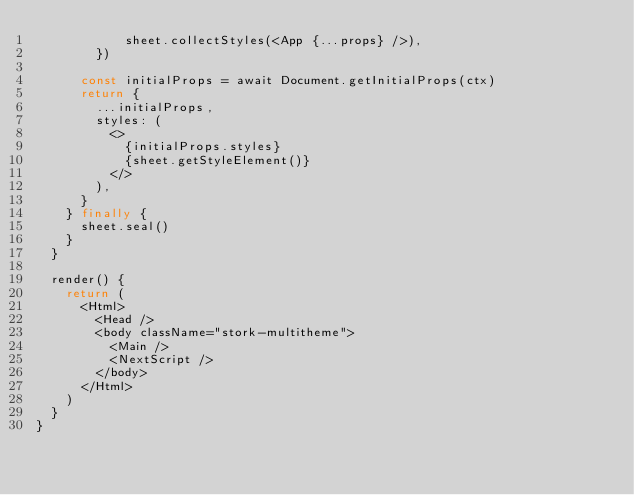<code> <loc_0><loc_0><loc_500><loc_500><_JavaScript_>            sheet.collectStyles(<App {...props} />),
        })

      const initialProps = await Document.getInitialProps(ctx)
      return {
        ...initialProps,
        styles: (
          <>
            {initialProps.styles}
            {sheet.getStyleElement()}
          </>
        ),
      }
    } finally {
      sheet.seal()
    }
  }

  render() {
    return (
      <Html>
        <Head />
        <body className="stork-multitheme">
          <Main />
          <NextScript />
        </body>
      </Html>
    )
  }
}
</code> 